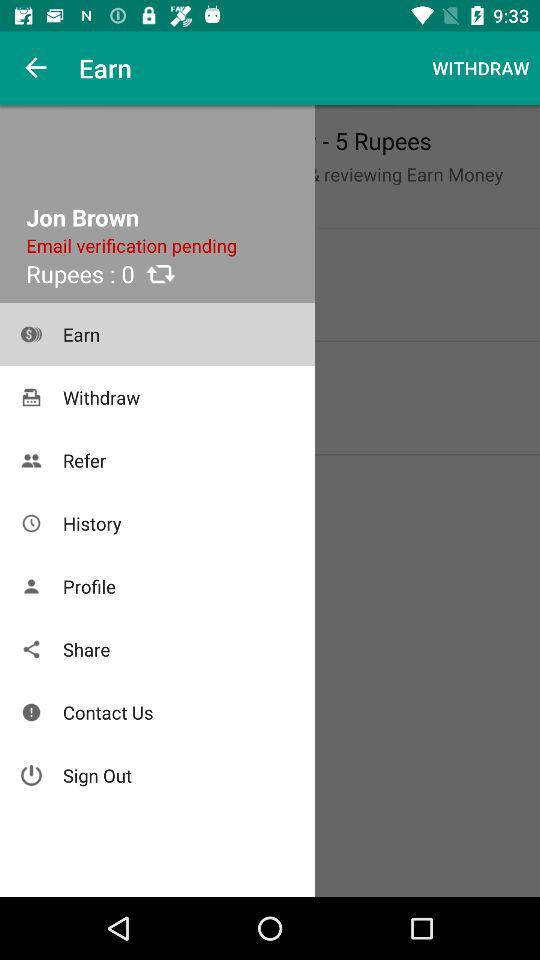How much money do I have in my account?
Answer the question using a single word or phrase. -5 Rupees 